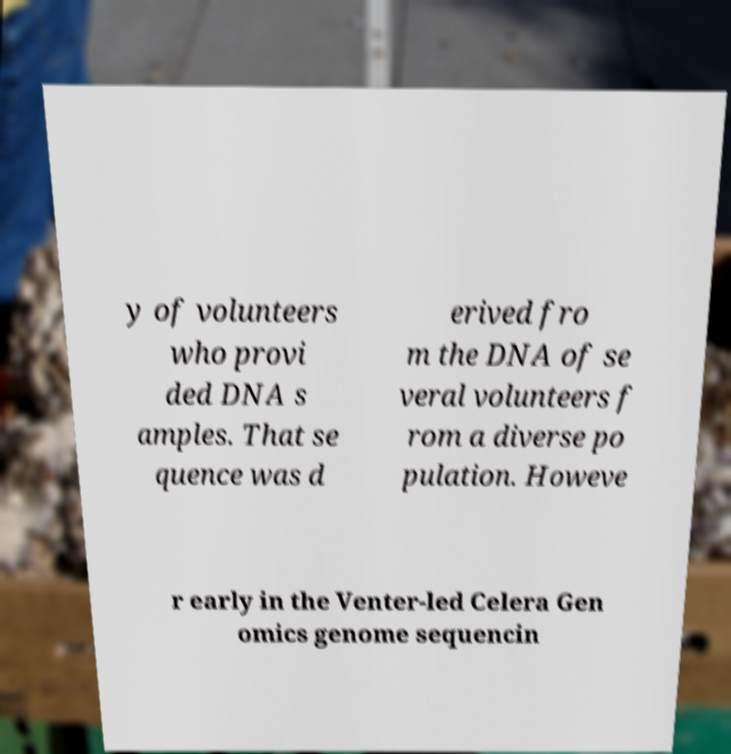For documentation purposes, I need the text within this image transcribed. Could you provide that? y of volunteers who provi ded DNA s amples. That se quence was d erived fro m the DNA of se veral volunteers f rom a diverse po pulation. Howeve r early in the Venter-led Celera Gen omics genome sequencin 